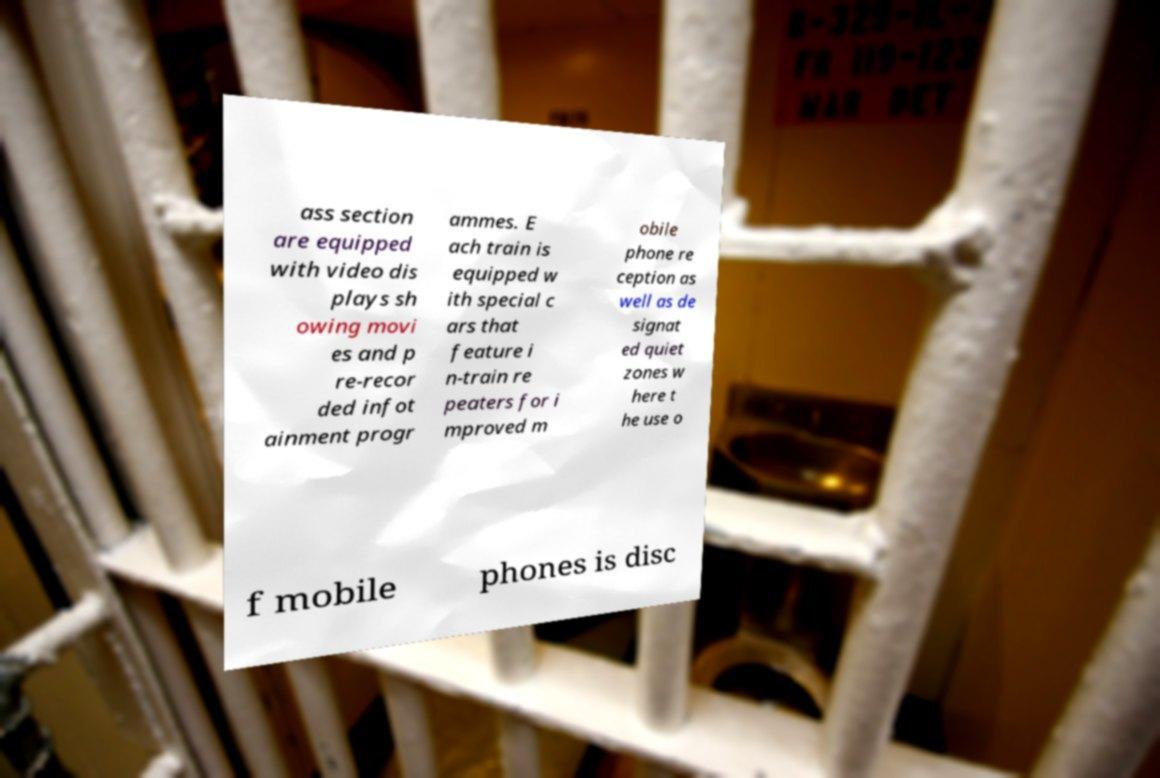There's text embedded in this image that I need extracted. Can you transcribe it verbatim? ass section are equipped with video dis plays sh owing movi es and p re-recor ded infot ainment progr ammes. E ach train is equipped w ith special c ars that feature i n-train re peaters for i mproved m obile phone re ception as well as de signat ed quiet zones w here t he use o f mobile phones is disc 